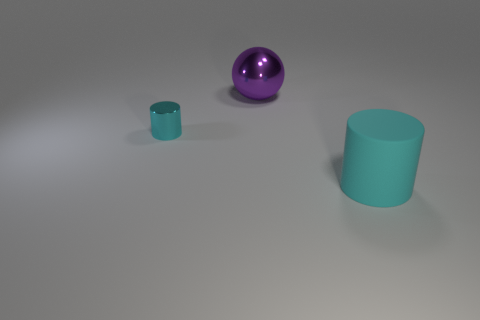Add 2 spheres. How many objects exist? 5 Subtract all cylinders. How many objects are left? 1 Add 3 metal objects. How many metal objects are left? 5 Add 1 large rubber things. How many large rubber things exist? 2 Subtract 0 brown blocks. How many objects are left? 3 Subtract all metallic cylinders. Subtract all cyan rubber things. How many objects are left? 1 